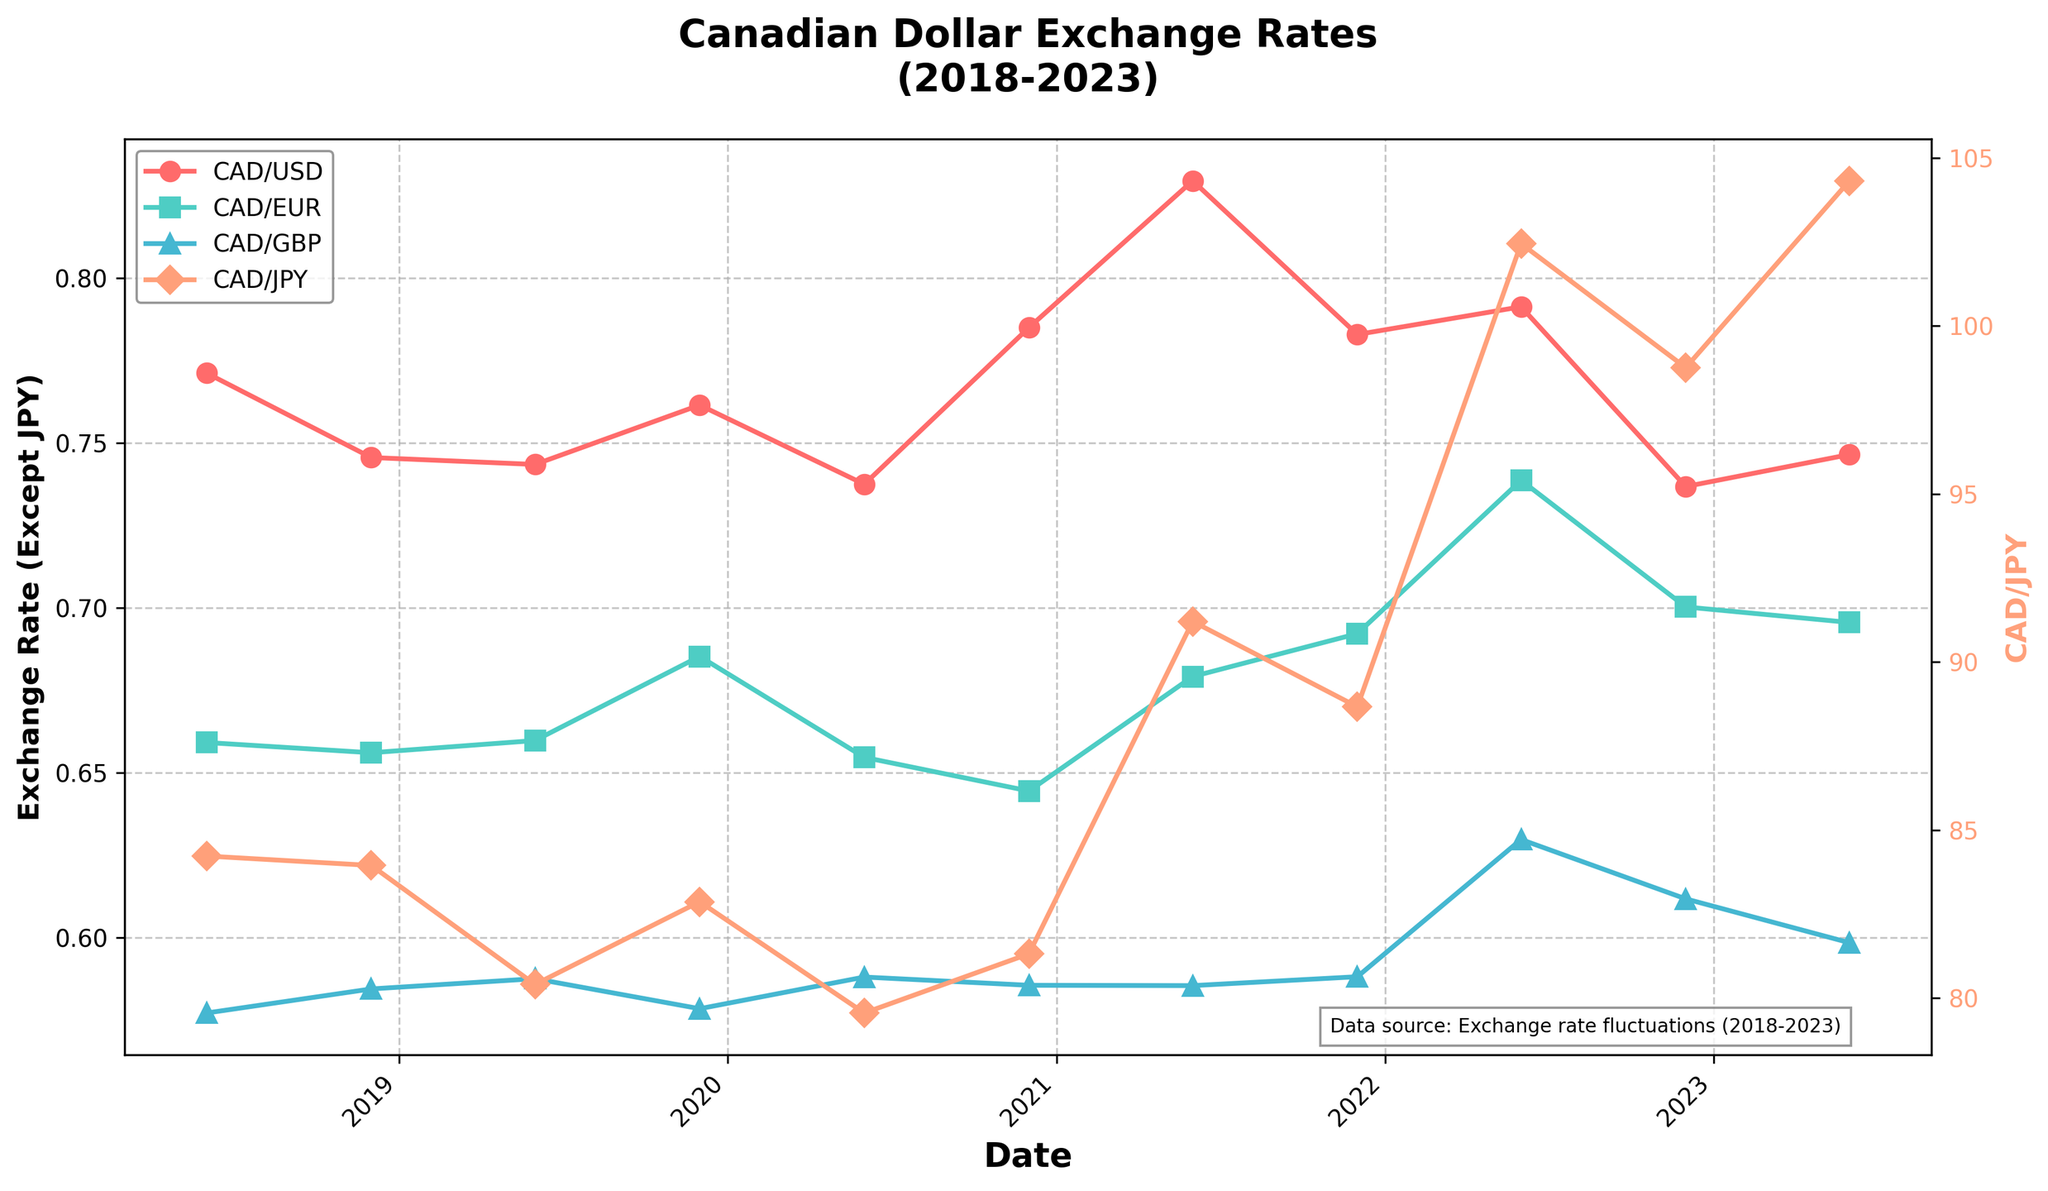What's the trend of CAD/USD from 2018 to 2023? The CAD/USD exchange rate starts at 0.7712 in June 2018 and sees fluctuations over the five-year period, peaking at 0.8295 in June 2021 and ending at 0.7465 in June 2023. The overall trend shows fluctuations with peaks in mid-2021 and a decline towards the end.
Answer: Fluctuating, peaking mid-2021 Which currency, excluding CAD/JPY, maintained the highest exchange rate against CAD throughout the period? By visually comparing the plots for CAD/USD, CAD/EUR, and CAD/GBP, CAD/USD is consistently higher relative to CAD.
Answer: CAD/USD In which year did CAD/JPY have the highest exchange rate? By checking the green line representing CAD/JPY in the plot, the highest point is observed in June 2023, indicating the highest exchange rate.
Answer: 2023 How does CAD/USD in June 2021 compare to CAD/EUR in the same month? Locate the points for June 2021 on both CAD/USD and CAD/EUR lines. CAD/USD is approximately 0.8295, while CAD/EUR is around 0.6792, showing that CAD/USD is higher.
Answer: CAD/USD is higher What is the year-on-year change in CAD/JPY from June 2022 to June 2023? CAD/JPY in June 2022 is approximately 102.45, and in June 2023, it is about 104.32. The year-on-year change can be calculated as 104.32 - 102.45 = 1.87.
Answer: 1.87 At what time did CAD/EUR peak and what was its value? Locate the highest point on the blue line representing CAD/EUR, which is in June 2022, with the value being approximately 0.7387.
Answer: June 2022, 0.7387 Between December 2020 and June 2021, which currency had the largest increase in exchange rate against CAD? Compare the difference for each currency between these dates. CAD/USD changes from 0.7850 to 0.8295, CAD/EUR from 0.6445 to 0.6792, CAD/GBP from 0.5856 to 0.5855 (no increase), and CAD/JPY from 81.32 to 91.21. The largest increase in terms of percentage appears for CAD/JPY.
Answer: CAD/JPY In what month and year did CAD/USD reach its lowest point on the chart? The lowest point in the red line representing CAD/USD is in December 2022, with the value being approximately 0.7368.
Answer: December 2022 How does the trend of CAD/GBP compare to CAD/EUR over the period? Throughout the period, both CAD/GBP and CAD/EUR increase and decrease but CAD/EUR shows a more significant upward trend in mid-2022 compared to CAD/GBP, which remains relatively stable.
Answer: CAD/EUR shows more rise What was the average exchange rate of CAD/USD over the five-year period? Summing up the CAD/USD values (0.7712 + 0.7456 + 0.7435 + 0.7615 + 0.7375 + 0.7850 + 0.8295 + 0.7829 + 0.7913 + 0.7368 + 0.7465) and dividing by 11, the average is approximately [(7.43 +1)*0.75]+0.15/11 = 0.7646
Answer: 0.7646 